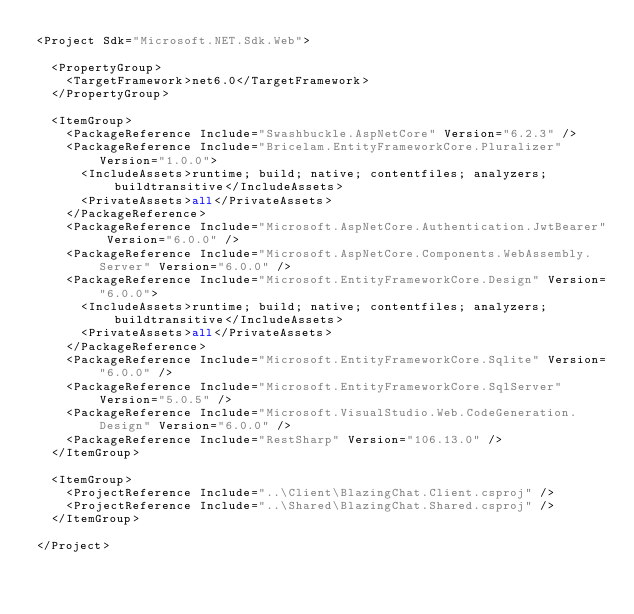Convert code to text. <code><loc_0><loc_0><loc_500><loc_500><_XML_><Project Sdk="Microsoft.NET.Sdk.Web">

  <PropertyGroup>
    <TargetFramework>net6.0</TargetFramework>
  </PropertyGroup>

  <ItemGroup>
    <PackageReference Include="Swashbuckle.AspNetCore" Version="6.2.3" />
    <PackageReference Include="Bricelam.EntityFrameworkCore.Pluralizer" Version="1.0.0">
      <IncludeAssets>runtime; build; native; contentfiles; analyzers; buildtransitive</IncludeAssets>
      <PrivateAssets>all</PrivateAssets>
    </PackageReference>
    <PackageReference Include="Microsoft.AspNetCore.Authentication.JwtBearer" Version="6.0.0" />
    <PackageReference Include="Microsoft.AspNetCore.Components.WebAssembly.Server" Version="6.0.0" />
    <PackageReference Include="Microsoft.EntityFrameworkCore.Design" Version="6.0.0">
      <IncludeAssets>runtime; build; native; contentfiles; analyzers; buildtransitive</IncludeAssets>
      <PrivateAssets>all</PrivateAssets>
    </PackageReference>
    <PackageReference Include="Microsoft.EntityFrameworkCore.Sqlite" Version="6.0.0" />
    <PackageReference Include="Microsoft.EntityFrameworkCore.SqlServer" Version="5.0.5" />
    <PackageReference Include="Microsoft.VisualStudio.Web.CodeGeneration.Design" Version="6.0.0" />
    <PackageReference Include="RestSharp" Version="106.13.0" />
  </ItemGroup>

  <ItemGroup>
    <ProjectReference Include="..\Client\BlazingChat.Client.csproj" />
    <ProjectReference Include="..\Shared\BlazingChat.Shared.csproj" />
  </ItemGroup>

</Project>
</code> 